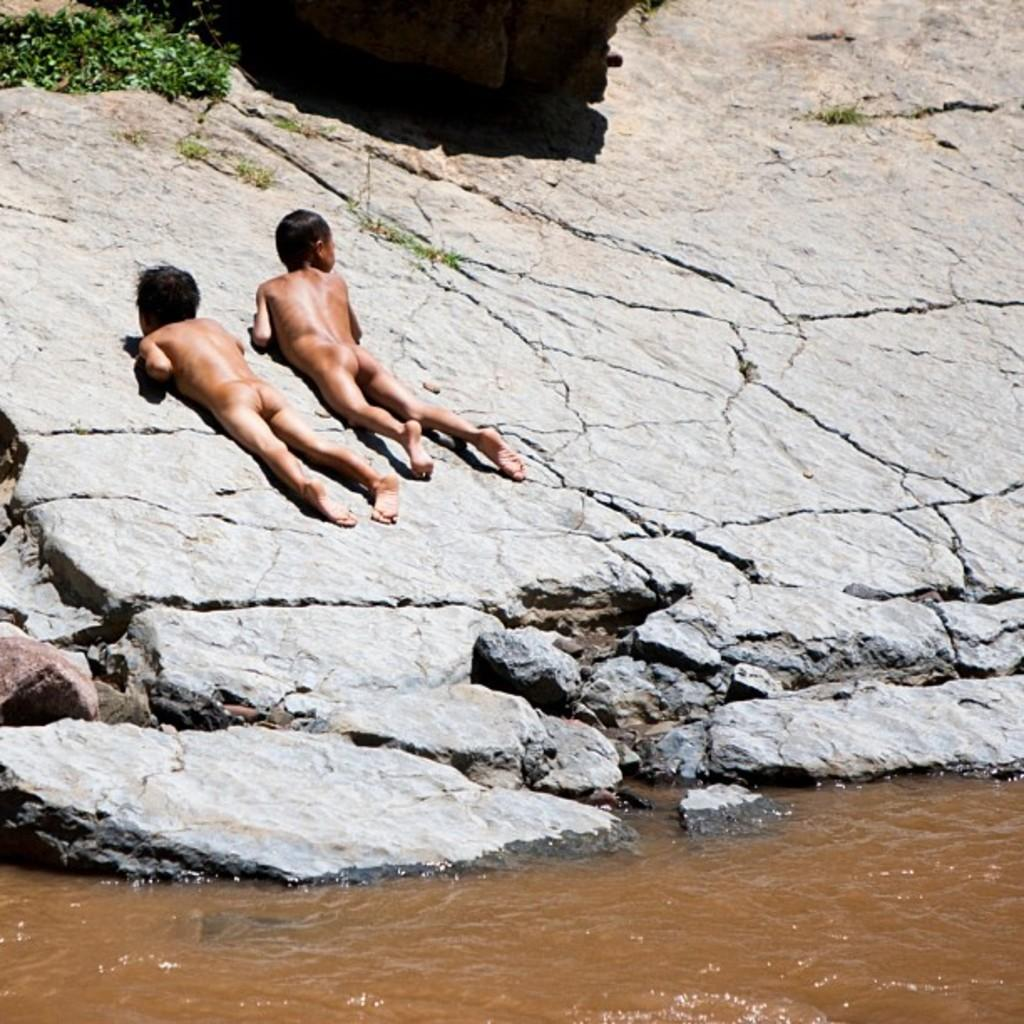What is present at the bottom of the image? There is water at the bottom of the image. What are the children doing in the image? The children are lying on rocks in the image. What type of vegetation can be seen in the top left side of the image? There is greenery in the top left side of the image. Where can the planes be seen in the image? There are no planes present in the image. What type of bun is being used as a prop in the image? There is no bun present in the image. 